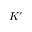Convert formula to latex. <formula><loc_0><loc_0><loc_500><loc_500>K ^ { \prime }</formula> 